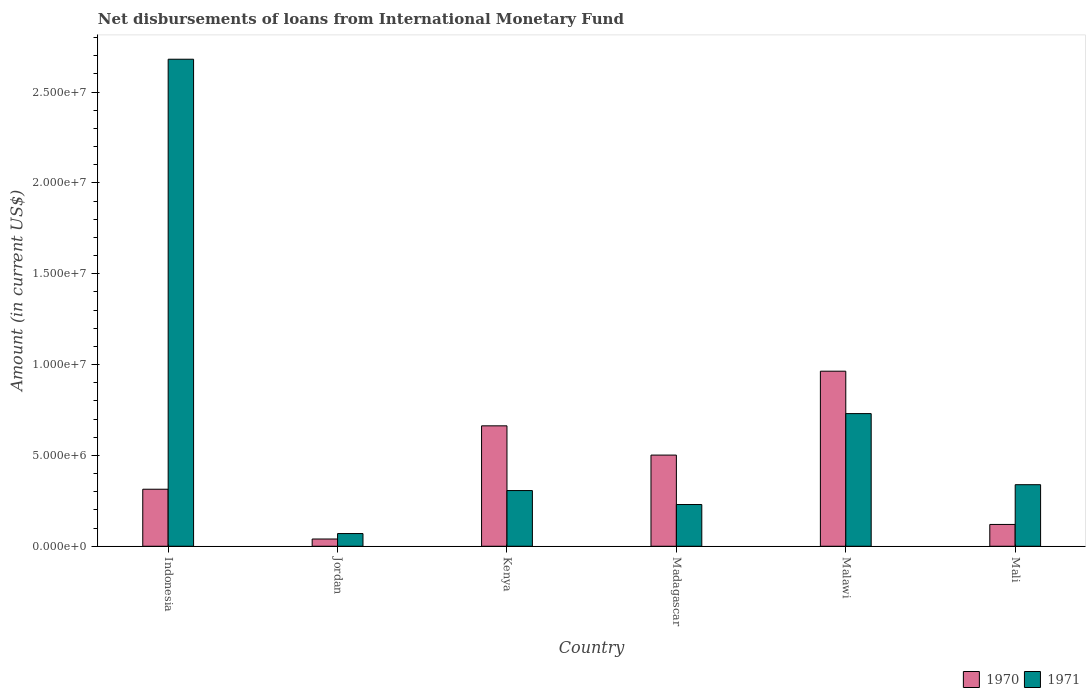How many different coloured bars are there?
Ensure brevity in your answer.  2. How many groups of bars are there?
Provide a short and direct response. 6. How many bars are there on the 4th tick from the left?
Your answer should be very brief. 2. How many bars are there on the 6th tick from the right?
Your answer should be very brief. 2. What is the label of the 5th group of bars from the left?
Your answer should be very brief. Malawi. In how many cases, is the number of bars for a given country not equal to the number of legend labels?
Ensure brevity in your answer.  0. What is the amount of loans disbursed in 1971 in Indonesia?
Ensure brevity in your answer.  2.68e+07. Across all countries, what is the maximum amount of loans disbursed in 1970?
Keep it short and to the point. 9.64e+06. Across all countries, what is the minimum amount of loans disbursed in 1971?
Give a very brief answer. 6.99e+05. In which country was the amount of loans disbursed in 1970 maximum?
Your answer should be very brief. Malawi. In which country was the amount of loans disbursed in 1971 minimum?
Provide a short and direct response. Jordan. What is the total amount of loans disbursed in 1970 in the graph?
Provide a short and direct response. 2.60e+07. What is the difference between the amount of loans disbursed in 1970 in Indonesia and that in Madagascar?
Provide a short and direct response. -1.88e+06. What is the difference between the amount of loans disbursed in 1971 in Kenya and the amount of loans disbursed in 1970 in Jordan?
Make the answer very short. 2.67e+06. What is the average amount of loans disbursed in 1970 per country?
Make the answer very short. 4.34e+06. What is the difference between the amount of loans disbursed of/in 1970 and amount of loans disbursed of/in 1971 in Mali?
Your answer should be compact. -2.19e+06. In how many countries, is the amount of loans disbursed in 1971 greater than 6000000 US$?
Provide a succinct answer. 2. What is the ratio of the amount of loans disbursed in 1971 in Jordan to that in Mali?
Make the answer very short. 0.21. Is the amount of loans disbursed in 1970 in Jordan less than that in Madagascar?
Your response must be concise. Yes. What is the difference between the highest and the second highest amount of loans disbursed in 1970?
Ensure brevity in your answer.  4.62e+06. What is the difference between the highest and the lowest amount of loans disbursed in 1971?
Your answer should be very brief. 2.61e+07. In how many countries, is the amount of loans disbursed in 1971 greater than the average amount of loans disbursed in 1971 taken over all countries?
Keep it short and to the point. 2. Is the sum of the amount of loans disbursed in 1970 in Indonesia and Madagascar greater than the maximum amount of loans disbursed in 1971 across all countries?
Give a very brief answer. No. What does the 1st bar from the right in Jordan represents?
Ensure brevity in your answer.  1971. How many bars are there?
Ensure brevity in your answer.  12. Are all the bars in the graph horizontal?
Offer a very short reply. No. What is the difference between two consecutive major ticks on the Y-axis?
Make the answer very short. 5.00e+06. Are the values on the major ticks of Y-axis written in scientific E-notation?
Offer a terse response. Yes. Does the graph contain any zero values?
Your answer should be compact. No. Does the graph contain grids?
Give a very brief answer. No. Where does the legend appear in the graph?
Make the answer very short. Bottom right. How many legend labels are there?
Keep it short and to the point. 2. How are the legend labels stacked?
Give a very brief answer. Horizontal. What is the title of the graph?
Your answer should be very brief. Net disbursements of loans from International Monetary Fund. Does "1961" appear as one of the legend labels in the graph?
Keep it short and to the point. No. What is the label or title of the Y-axis?
Make the answer very short. Amount (in current US$). What is the Amount (in current US$) of 1970 in Indonesia?
Make the answer very short. 3.14e+06. What is the Amount (in current US$) of 1971 in Indonesia?
Your answer should be very brief. 2.68e+07. What is the Amount (in current US$) of 1970 in Jordan?
Your response must be concise. 3.99e+05. What is the Amount (in current US$) of 1971 in Jordan?
Your answer should be compact. 6.99e+05. What is the Amount (in current US$) of 1970 in Kenya?
Provide a short and direct response. 6.63e+06. What is the Amount (in current US$) in 1971 in Kenya?
Give a very brief answer. 3.07e+06. What is the Amount (in current US$) in 1970 in Madagascar?
Your answer should be compact. 5.02e+06. What is the Amount (in current US$) in 1971 in Madagascar?
Offer a terse response. 2.30e+06. What is the Amount (in current US$) of 1970 in Malawi?
Offer a terse response. 9.64e+06. What is the Amount (in current US$) of 1971 in Malawi?
Provide a short and direct response. 7.30e+06. What is the Amount (in current US$) of 1970 in Mali?
Your answer should be very brief. 1.20e+06. What is the Amount (in current US$) of 1971 in Mali?
Provide a succinct answer. 3.39e+06. Across all countries, what is the maximum Amount (in current US$) of 1970?
Make the answer very short. 9.64e+06. Across all countries, what is the maximum Amount (in current US$) of 1971?
Your response must be concise. 2.68e+07. Across all countries, what is the minimum Amount (in current US$) in 1970?
Ensure brevity in your answer.  3.99e+05. Across all countries, what is the minimum Amount (in current US$) of 1971?
Your response must be concise. 6.99e+05. What is the total Amount (in current US$) in 1970 in the graph?
Provide a short and direct response. 2.60e+07. What is the total Amount (in current US$) in 1971 in the graph?
Ensure brevity in your answer.  4.36e+07. What is the difference between the Amount (in current US$) of 1970 in Indonesia and that in Jordan?
Offer a terse response. 2.74e+06. What is the difference between the Amount (in current US$) in 1971 in Indonesia and that in Jordan?
Make the answer very short. 2.61e+07. What is the difference between the Amount (in current US$) in 1970 in Indonesia and that in Kenya?
Ensure brevity in your answer.  -3.49e+06. What is the difference between the Amount (in current US$) in 1971 in Indonesia and that in Kenya?
Your answer should be very brief. 2.37e+07. What is the difference between the Amount (in current US$) of 1970 in Indonesia and that in Madagascar?
Keep it short and to the point. -1.88e+06. What is the difference between the Amount (in current US$) in 1971 in Indonesia and that in Madagascar?
Your response must be concise. 2.45e+07. What is the difference between the Amount (in current US$) of 1970 in Indonesia and that in Malawi?
Give a very brief answer. -6.50e+06. What is the difference between the Amount (in current US$) of 1971 in Indonesia and that in Malawi?
Offer a very short reply. 1.95e+07. What is the difference between the Amount (in current US$) in 1970 in Indonesia and that in Mali?
Provide a succinct answer. 1.94e+06. What is the difference between the Amount (in current US$) in 1971 in Indonesia and that in Mali?
Offer a terse response. 2.34e+07. What is the difference between the Amount (in current US$) in 1970 in Jordan and that in Kenya?
Your response must be concise. -6.23e+06. What is the difference between the Amount (in current US$) in 1971 in Jordan and that in Kenya?
Make the answer very short. -2.37e+06. What is the difference between the Amount (in current US$) of 1970 in Jordan and that in Madagascar?
Provide a short and direct response. -4.62e+06. What is the difference between the Amount (in current US$) of 1971 in Jordan and that in Madagascar?
Your answer should be very brief. -1.60e+06. What is the difference between the Amount (in current US$) of 1970 in Jordan and that in Malawi?
Provide a succinct answer. -9.24e+06. What is the difference between the Amount (in current US$) in 1971 in Jordan and that in Malawi?
Your answer should be compact. -6.60e+06. What is the difference between the Amount (in current US$) of 1970 in Jordan and that in Mali?
Provide a succinct answer. -8.01e+05. What is the difference between the Amount (in current US$) of 1971 in Jordan and that in Mali?
Ensure brevity in your answer.  -2.69e+06. What is the difference between the Amount (in current US$) of 1970 in Kenya and that in Madagascar?
Ensure brevity in your answer.  1.61e+06. What is the difference between the Amount (in current US$) in 1971 in Kenya and that in Madagascar?
Offer a very short reply. 7.69e+05. What is the difference between the Amount (in current US$) of 1970 in Kenya and that in Malawi?
Provide a short and direct response. -3.01e+06. What is the difference between the Amount (in current US$) in 1971 in Kenya and that in Malawi?
Your answer should be compact. -4.24e+06. What is the difference between the Amount (in current US$) of 1970 in Kenya and that in Mali?
Provide a succinct answer. 5.43e+06. What is the difference between the Amount (in current US$) of 1971 in Kenya and that in Mali?
Provide a succinct answer. -3.22e+05. What is the difference between the Amount (in current US$) of 1970 in Madagascar and that in Malawi?
Give a very brief answer. -4.62e+06. What is the difference between the Amount (in current US$) of 1971 in Madagascar and that in Malawi?
Your answer should be compact. -5.00e+06. What is the difference between the Amount (in current US$) of 1970 in Madagascar and that in Mali?
Keep it short and to the point. 3.82e+06. What is the difference between the Amount (in current US$) of 1971 in Madagascar and that in Mali?
Ensure brevity in your answer.  -1.09e+06. What is the difference between the Amount (in current US$) in 1970 in Malawi and that in Mali?
Ensure brevity in your answer.  8.44e+06. What is the difference between the Amount (in current US$) of 1971 in Malawi and that in Mali?
Give a very brief answer. 3.91e+06. What is the difference between the Amount (in current US$) of 1970 in Indonesia and the Amount (in current US$) of 1971 in Jordan?
Your answer should be compact. 2.44e+06. What is the difference between the Amount (in current US$) of 1970 in Indonesia and the Amount (in current US$) of 1971 in Kenya?
Provide a short and direct response. 7.30e+04. What is the difference between the Amount (in current US$) in 1970 in Indonesia and the Amount (in current US$) in 1971 in Madagascar?
Keep it short and to the point. 8.42e+05. What is the difference between the Amount (in current US$) in 1970 in Indonesia and the Amount (in current US$) in 1971 in Malawi?
Provide a short and direct response. -4.16e+06. What is the difference between the Amount (in current US$) of 1970 in Indonesia and the Amount (in current US$) of 1971 in Mali?
Make the answer very short. -2.49e+05. What is the difference between the Amount (in current US$) of 1970 in Jordan and the Amount (in current US$) of 1971 in Kenya?
Give a very brief answer. -2.67e+06. What is the difference between the Amount (in current US$) in 1970 in Jordan and the Amount (in current US$) in 1971 in Madagascar?
Offer a very short reply. -1.90e+06. What is the difference between the Amount (in current US$) of 1970 in Jordan and the Amount (in current US$) of 1971 in Malawi?
Ensure brevity in your answer.  -6.90e+06. What is the difference between the Amount (in current US$) of 1970 in Jordan and the Amount (in current US$) of 1971 in Mali?
Keep it short and to the point. -2.99e+06. What is the difference between the Amount (in current US$) of 1970 in Kenya and the Amount (in current US$) of 1971 in Madagascar?
Your response must be concise. 4.33e+06. What is the difference between the Amount (in current US$) of 1970 in Kenya and the Amount (in current US$) of 1971 in Malawi?
Keep it short and to the point. -6.74e+05. What is the difference between the Amount (in current US$) in 1970 in Kenya and the Amount (in current US$) in 1971 in Mali?
Make the answer very short. 3.24e+06. What is the difference between the Amount (in current US$) in 1970 in Madagascar and the Amount (in current US$) in 1971 in Malawi?
Your answer should be very brief. -2.28e+06. What is the difference between the Amount (in current US$) in 1970 in Madagascar and the Amount (in current US$) in 1971 in Mali?
Offer a terse response. 1.63e+06. What is the difference between the Amount (in current US$) of 1970 in Malawi and the Amount (in current US$) of 1971 in Mali?
Keep it short and to the point. 6.25e+06. What is the average Amount (in current US$) of 1970 per country?
Your answer should be compact. 4.34e+06. What is the average Amount (in current US$) in 1971 per country?
Make the answer very short. 7.26e+06. What is the difference between the Amount (in current US$) of 1970 and Amount (in current US$) of 1971 in Indonesia?
Your answer should be very brief. -2.37e+07. What is the difference between the Amount (in current US$) in 1970 and Amount (in current US$) in 1971 in Jordan?
Give a very brief answer. -3.00e+05. What is the difference between the Amount (in current US$) of 1970 and Amount (in current US$) of 1971 in Kenya?
Ensure brevity in your answer.  3.56e+06. What is the difference between the Amount (in current US$) of 1970 and Amount (in current US$) of 1971 in Madagascar?
Ensure brevity in your answer.  2.72e+06. What is the difference between the Amount (in current US$) in 1970 and Amount (in current US$) in 1971 in Malawi?
Give a very brief answer. 2.33e+06. What is the difference between the Amount (in current US$) in 1970 and Amount (in current US$) in 1971 in Mali?
Keep it short and to the point. -2.19e+06. What is the ratio of the Amount (in current US$) in 1970 in Indonesia to that in Jordan?
Ensure brevity in your answer.  7.87. What is the ratio of the Amount (in current US$) of 1971 in Indonesia to that in Jordan?
Make the answer very short. 38.35. What is the ratio of the Amount (in current US$) in 1970 in Indonesia to that in Kenya?
Your answer should be very brief. 0.47. What is the ratio of the Amount (in current US$) of 1971 in Indonesia to that in Kenya?
Your answer should be compact. 8.74. What is the ratio of the Amount (in current US$) of 1970 in Indonesia to that in Madagascar?
Keep it short and to the point. 0.63. What is the ratio of the Amount (in current US$) of 1971 in Indonesia to that in Madagascar?
Give a very brief answer. 11.67. What is the ratio of the Amount (in current US$) of 1970 in Indonesia to that in Malawi?
Your answer should be compact. 0.33. What is the ratio of the Amount (in current US$) in 1971 in Indonesia to that in Malawi?
Keep it short and to the point. 3.67. What is the ratio of the Amount (in current US$) in 1970 in Indonesia to that in Mali?
Your answer should be compact. 2.62. What is the ratio of the Amount (in current US$) of 1971 in Indonesia to that in Mali?
Your answer should be very brief. 7.91. What is the ratio of the Amount (in current US$) in 1970 in Jordan to that in Kenya?
Offer a very short reply. 0.06. What is the ratio of the Amount (in current US$) of 1971 in Jordan to that in Kenya?
Your answer should be very brief. 0.23. What is the ratio of the Amount (in current US$) in 1970 in Jordan to that in Madagascar?
Offer a terse response. 0.08. What is the ratio of the Amount (in current US$) in 1971 in Jordan to that in Madagascar?
Your response must be concise. 0.3. What is the ratio of the Amount (in current US$) in 1970 in Jordan to that in Malawi?
Your answer should be compact. 0.04. What is the ratio of the Amount (in current US$) in 1971 in Jordan to that in Malawi?
Make the answer very short. 0.1. What is the ratio of the Amount (in current US$) in 1970 in Jordan to that in Mali?
Make the answer very short. 0.33. What is the ratio of the Amount (in current US$) of 1971 in Jordan to that in Mali?
Keep it short and to the point. 0.21. What is the ratio of the Amount (in current US$) in 1970 in Kenya to that in Madagascar?
Your answer should be very brief. 1.32. What is the ratio of the Amount (in current US$) in 1971 in Kenya to that in Madagascar?
Give a very brief answer. 1.33. What is the ratio of the Amount (in current US$) in 1970 in Kenya to that in Malawi?
Your answer should be very brief. 0.69. What is the ratio of the Amount (in current US$) in 1971 in Kenya to that in Malawi?
Make the answer very short. 0.42. What is the ratio of the Amount (in current US$) of 1970 in Kenya to that in Mali?
Your answer should be compact. 5.52. What is the ratio of the Amount (in current US$) in 1971 in Kenya to that in Mali?
Your response must be concise. 0.91. What is the ratio of the Amount (in current US$) of 1970 in Madagascar to that in Malawi?
Offer a terse response. 0.52. What is the ratio of the Amount (in current US$) of 1971 in Madagascar to that in Malawi?
Ensure brevity in your answer.  0.31. What is the ratio of the Amount (in current US$) of 1970 in Madagascar to that in Mali?
Provide a succinct answer. 4.18. What is the ratio of the Amount (in current US$) of 1971 in Madagascar to that in Mali?
Ensure brevity in your answer.  0.68. What is the ratio of the Amount (in current US$) in 1970 in Malawi to that in Mali?
Your answer should be compact. 8.03. What is the ratio of the Amount (in current US$) of 1971 in Malawi to that in Mali?
Offer a very short reply. 2.16. What is the difference between the highest and the second highest Amount (in current US$) of 1970?
Provide a short and direct response. 3.01e+06. What is the difference between the highest and the second highest Amount (in current US$) of 1971?
Provide a short and direct response. 1.95e+07. What is the difference between the highest and the lowest Amount (in current US$) in 1970?
Provide a short and direct response. 9.24e+06. What is the difference between the highest and the lowest Amount (in current US$) of 1971?
Your answer should be compact. 2.61e+07. 